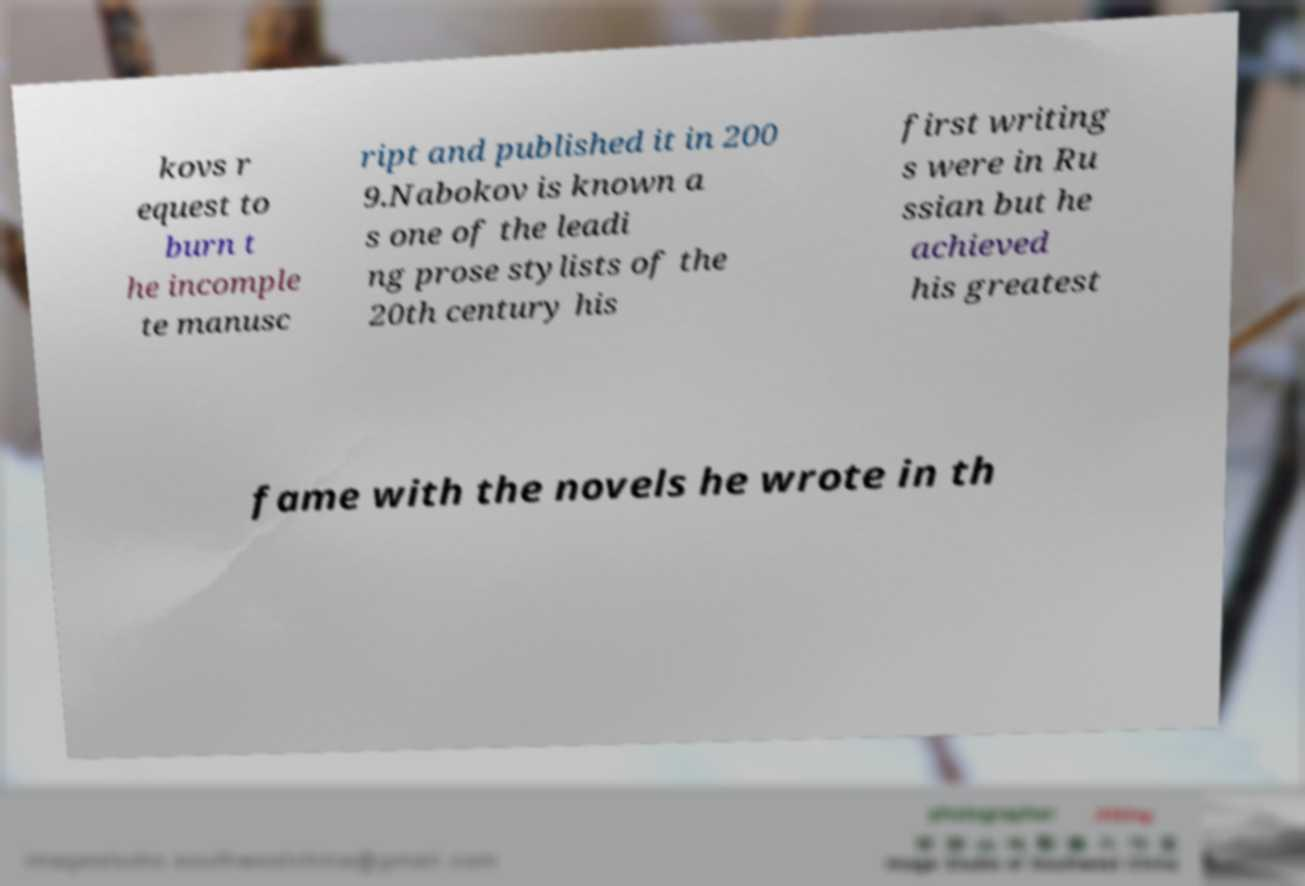Could you assist in decoding the text presented in this image and type it out clearly? kovs r equest to burn t he incomple te manusc ript and published it in 200 9.Nabokov is known a s one of the leadi ng prose stylists of the 20th century his first writing s were in Ru ssian but he achieved his greatest fame with the novels he wrote in th 